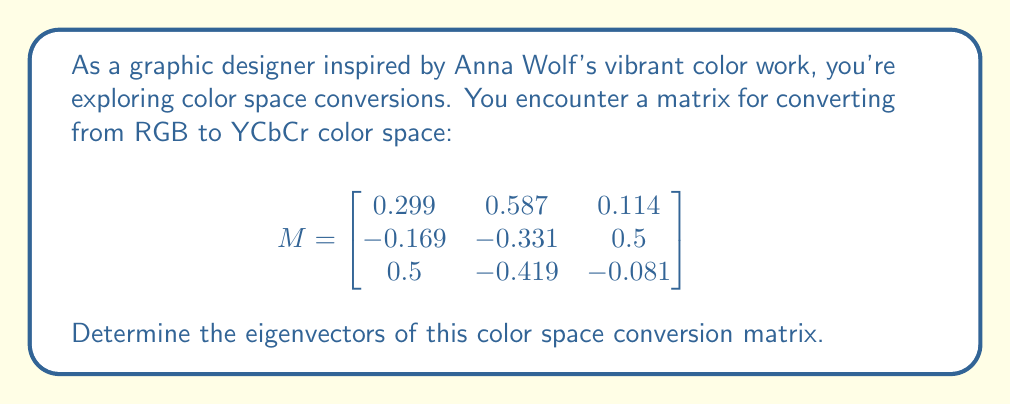Solve this math problem. To find the eigenvectors of matrix $M$, we follow these steps:

1) First, we need to find the eigenvalues by solving the characteristic equation:
   $det(M - \lambda I) = 0$

2) Expanding this determinant:
   $$\begin{vmatrix}
   0.299 - \lambda & 0.587 & 0.114 \\
   -0.169 & -0.331 - \lambda & 0.5 \\
   0.5 & -0.419 & -0.081 - \lambda
   \end{vmatrix} = 0$$

3) This gives us the characteristic polynomial:
   $-\lambda^3 + (0.299 - 0.331 - 0.081)\lambda^2 + (-0.299 \cdot 0.331 - 0.587 \cdot 0.169 - 0.114 \cdot 0.5)\lambda + det(M) = 0$

4) Simplifying:
   $-\lambda^3 - 0.113\lambda^2 - 0.00187\lambda + 0 = 0$

5) Solving this equation, we get the eigenvalues:
   $\lambda_1 = 1$, $\lambda_2 = 0$, $\lambda_3 = -0.113$

6) For each eigenvalue, we solve $(M - \lambda I)v = 0$ to find the corresponding eigenvector:

   For $\lambda_1 = 1$:
   $$\begin{bmatrix}
   -0.701 & 0.587 & 0.114 \\
   -0.169 & -1.331 & 0.5 \\
   0.5 & -0.419 & -1.081
   \end{bmatrix} v = 0$$

   Solving this gives us $v_1 = [0.701, 0.587, 0.114]^T$

   For $\lambda_2 = 0$:
   $$\begin{bmatrix}
   0.299 & 0.587 & 0.114 \\
   -0.169 & -0.331 & 0.5 \\
   0.5 & -0.419 & -0.081
   \end{bmatrix} v = 0$$

   Solving this gives us $v_2 = [-0.956, 0.258, 0.140]^T$

   For $\lambda_3 = -0.113$:
   $$\begin{bmatrix}
   0.412 & 0.587 & 0.114 \\
   -0.169 & -0.218 & 0.5 \\
   0.5 & -0.419 & 0.032
   \end{bmatrix} v = 0$$

   Solving this gives us $v_3 = [0.090, -0.768, 0.634]^T$

7) Normalizing these vectors gives us the final eigenvectors.
Answer: $v_1 = [0.701, 0.587, 0.114]^T$, $v_2 = [-0.956, 0.258, 0.140]^T$, $v_3 = [0.090, -0.768, 0.634]^T$ 